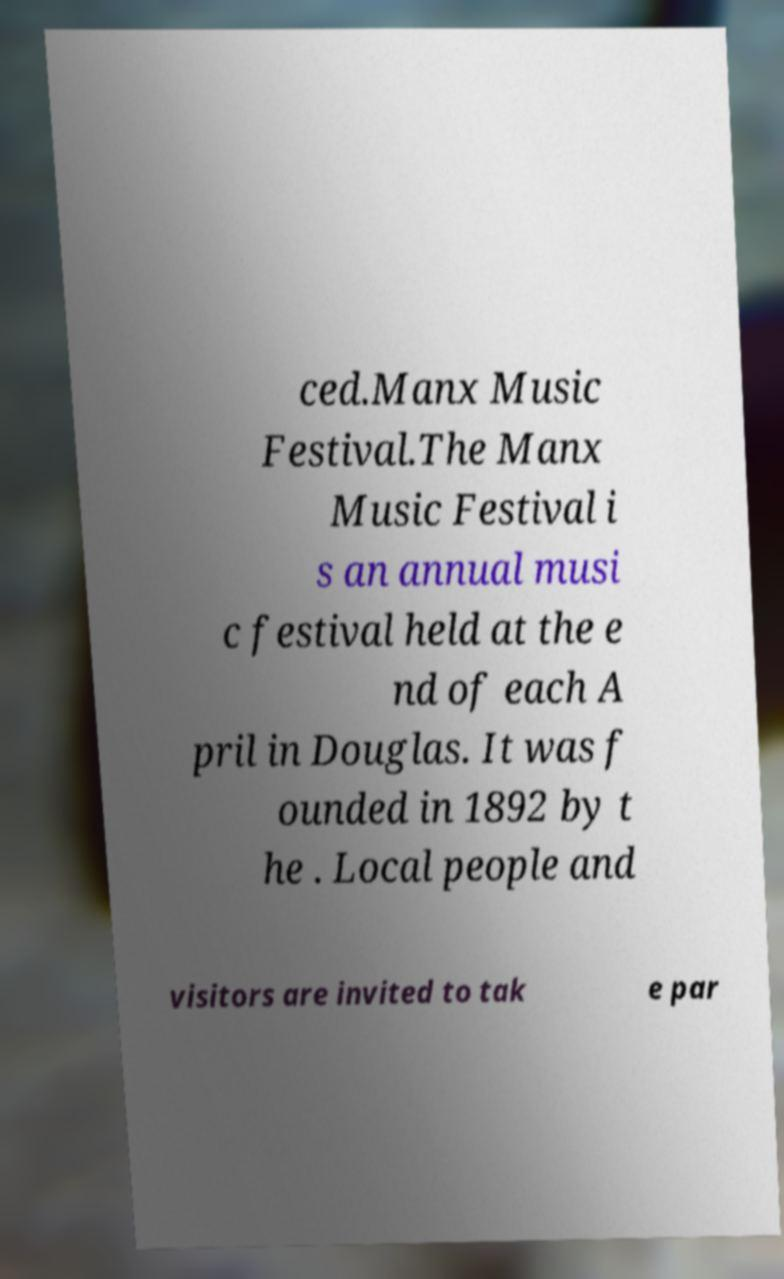Could you extract and type out the text from this image? ced.Manx Music Festival.The Manx Music Festival i s an annual musi c festival held at the e nd of each A pril in Douglas. It was f ounded in 1892 by t he . Local people and visitors are invited to tak e par 